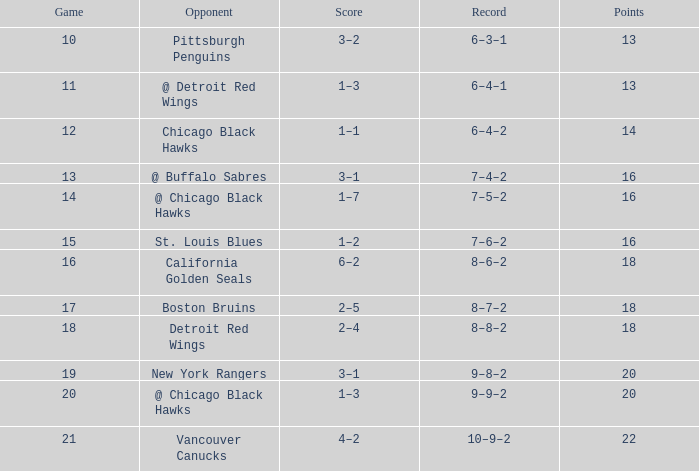Could you parse the entire table? {'header': ['Game', 'Opponent', 'Score', 'Record', 'Points'], 'rows': [['10', 'Pittsburgh Penguins', '3–2', '6–3–1', '13'], ['11', '@ Detroit Red Wings', '1–3', '6–4–1', '13'], ['12', 'Chicago Black Hawks', '1–1', '6–4–2', '14'], ['13', '@ Buffalo Sabres', '3–1', '7–4–2', '16'], ['14', '@ Chicago Black Hawks', '1–7', '7–5–2', '16'], ['15', 'St. Louis Blues', '1–2', '7–6–2', '16'], ['16', 'California Golden Seals', '6–2', '8–6–2', '18'], ['17', 'Boston Bruins', '2–5', '8–7–2', '18'], ['18', 'Detroit Red Wings', '2–4', '8–8–2', '18'], ['19', 'New York Rangers', '3–1', '9–8–2', '20'], ['20', '@ Chicago Black Hawks', '1–3', '9–9–2', '20'], ['21', 'Vancouver Canucks', '4–2', '10–9–2', '22']]} Which opponent has points less than 18, and a november greater than 11? St. Louis Blues. 